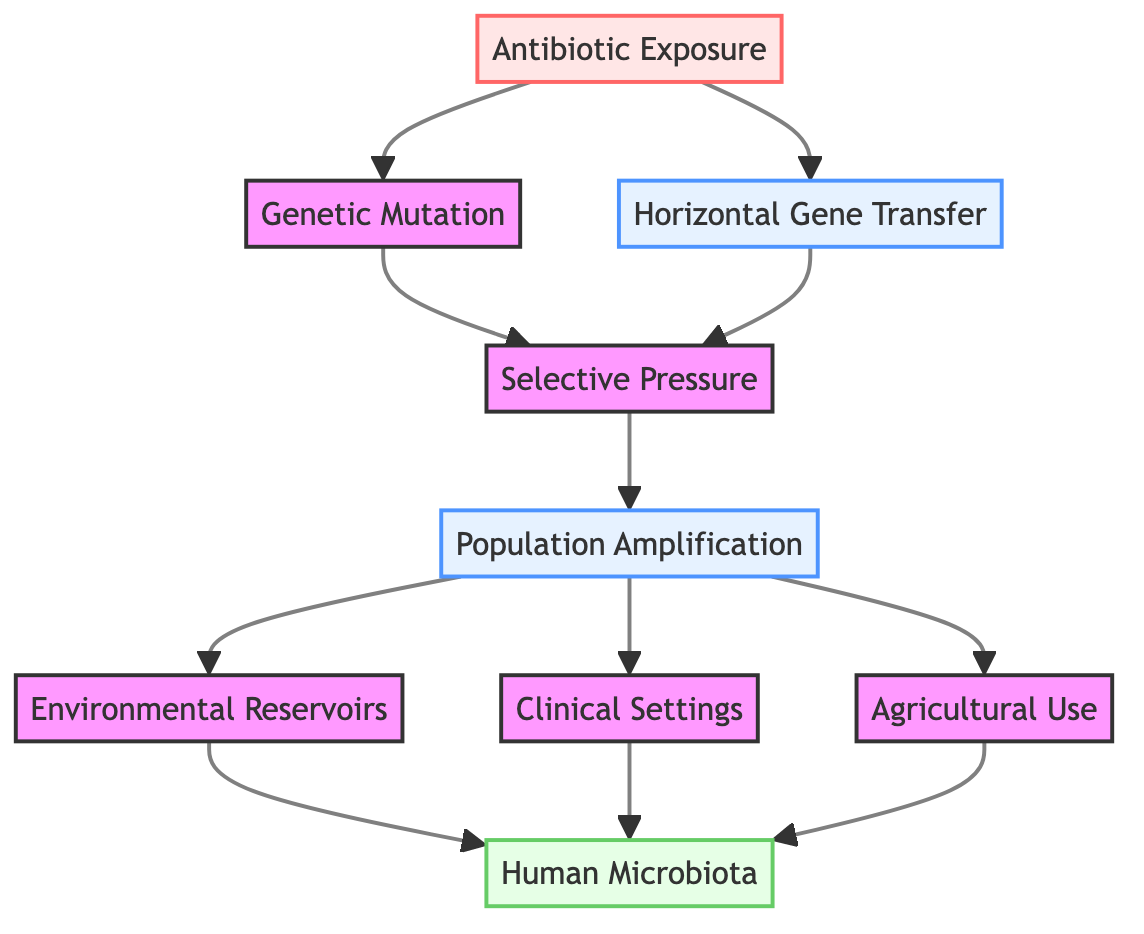What is the first step in the pathway of antibiotic resistance development? The first step indicated in the diagram is "Antibiotic Exposure," which shows the initial interaction of bacterial populations with antibiotics.
Answer: Antibiotic Exposure How many nodes are present in this flowchart? By counting all the distinct elements in the diagram, including the starting point and all connected nodes, there are a total of 9 nodes.
Answer: 9 What happens after "Selective Pressure"? Following "Selective Pressure," the next node in the flowchart is "Population Amplification," indicating the process where resistant bacteria increase in number.
Answer: Population Amplification Which node represents the mechanism that leads to antibiotic resistance due to genetic changes? The "Genetic Mutation" node represents one of the mechanisms leading to antibiotic resistance through spontaneous DNA changes in bacteria.
Answer: Genetic Mutation What connects "Environmental Reservoirs" and "Human Microbiota"? The flowchart indicates that "Environmental Reservoirs" feeds into "Human Microbiota," demonstrating a pathway where resistant bacteria in the environment colonize human bodies.
Answer: Environmental Reservoirs Which entities contribute to the presence of antibiotic resistance in "Human Microbiota"? The nodes leading to "Human Microbiota" are "Environmental Reservoirs," "Clinical Settings," and "Agricultural Use," indicating that all these contribute to the colonization of resistant bacteria.
Answer: Environmental Reservoirs, Clinical Settings, Agricultural Use What is the relationship between "Horizontal Gene Transfer" and "Selective Pressure"? "Horizontal Gene Transfer" is depicted as an input to "Selective Pressure," indicating that the transfer of resistance genes also entails a survival advantage under antibiotic conditions.
Answer: Relationship as input Identify the last node in the diagram. The last node in the pathway, showing the ultimate consequence of all processes described, is "Human Microbiota."
Answer: Human Microbiota What type of antibiotic resistance mechanism is represented by "Horizontal Gene Transfer"? "Horizontal Gene Transfer" represents the mechanism of transferring genetic material between bacteria, contributing to the spread of resistance.
Answer: Horizontal Gene Transfer What follows the "Antibiotic Exposure" in the pathway? The elements that arise directly after "Antibiotic Exposure" are "Genetic Mutation" and "Horizontal Gene Transfer," showcasing how exposure leads to resistance development in multiple ways.
Answer: Genetic Mutation, Horizontal Gene Transfer 